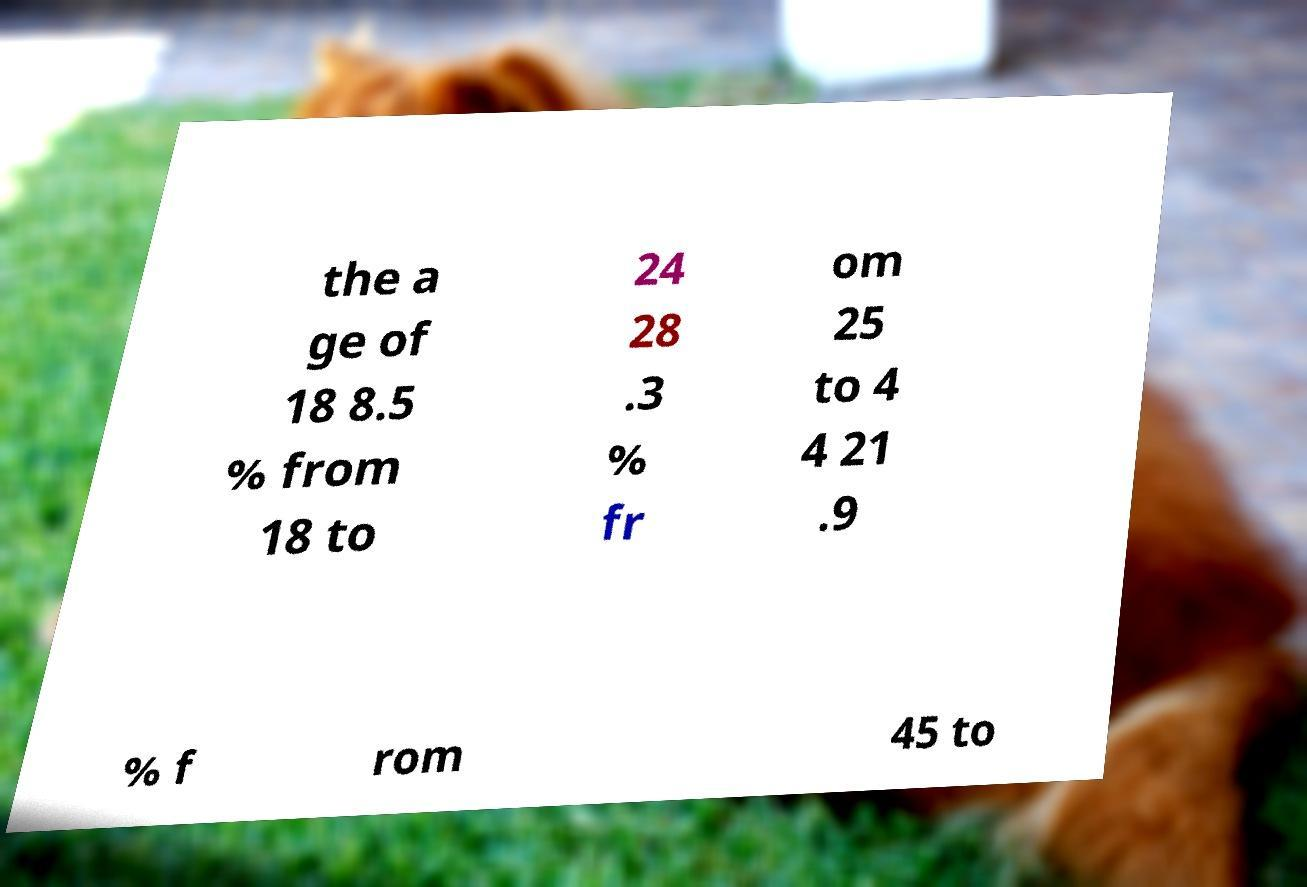Could you extract and type out the text from this image? the a ge of 18 8.5 % from 18 to 24 28 .3 % fr om 25 to 4 4 21 .9 % f rom 45 to 